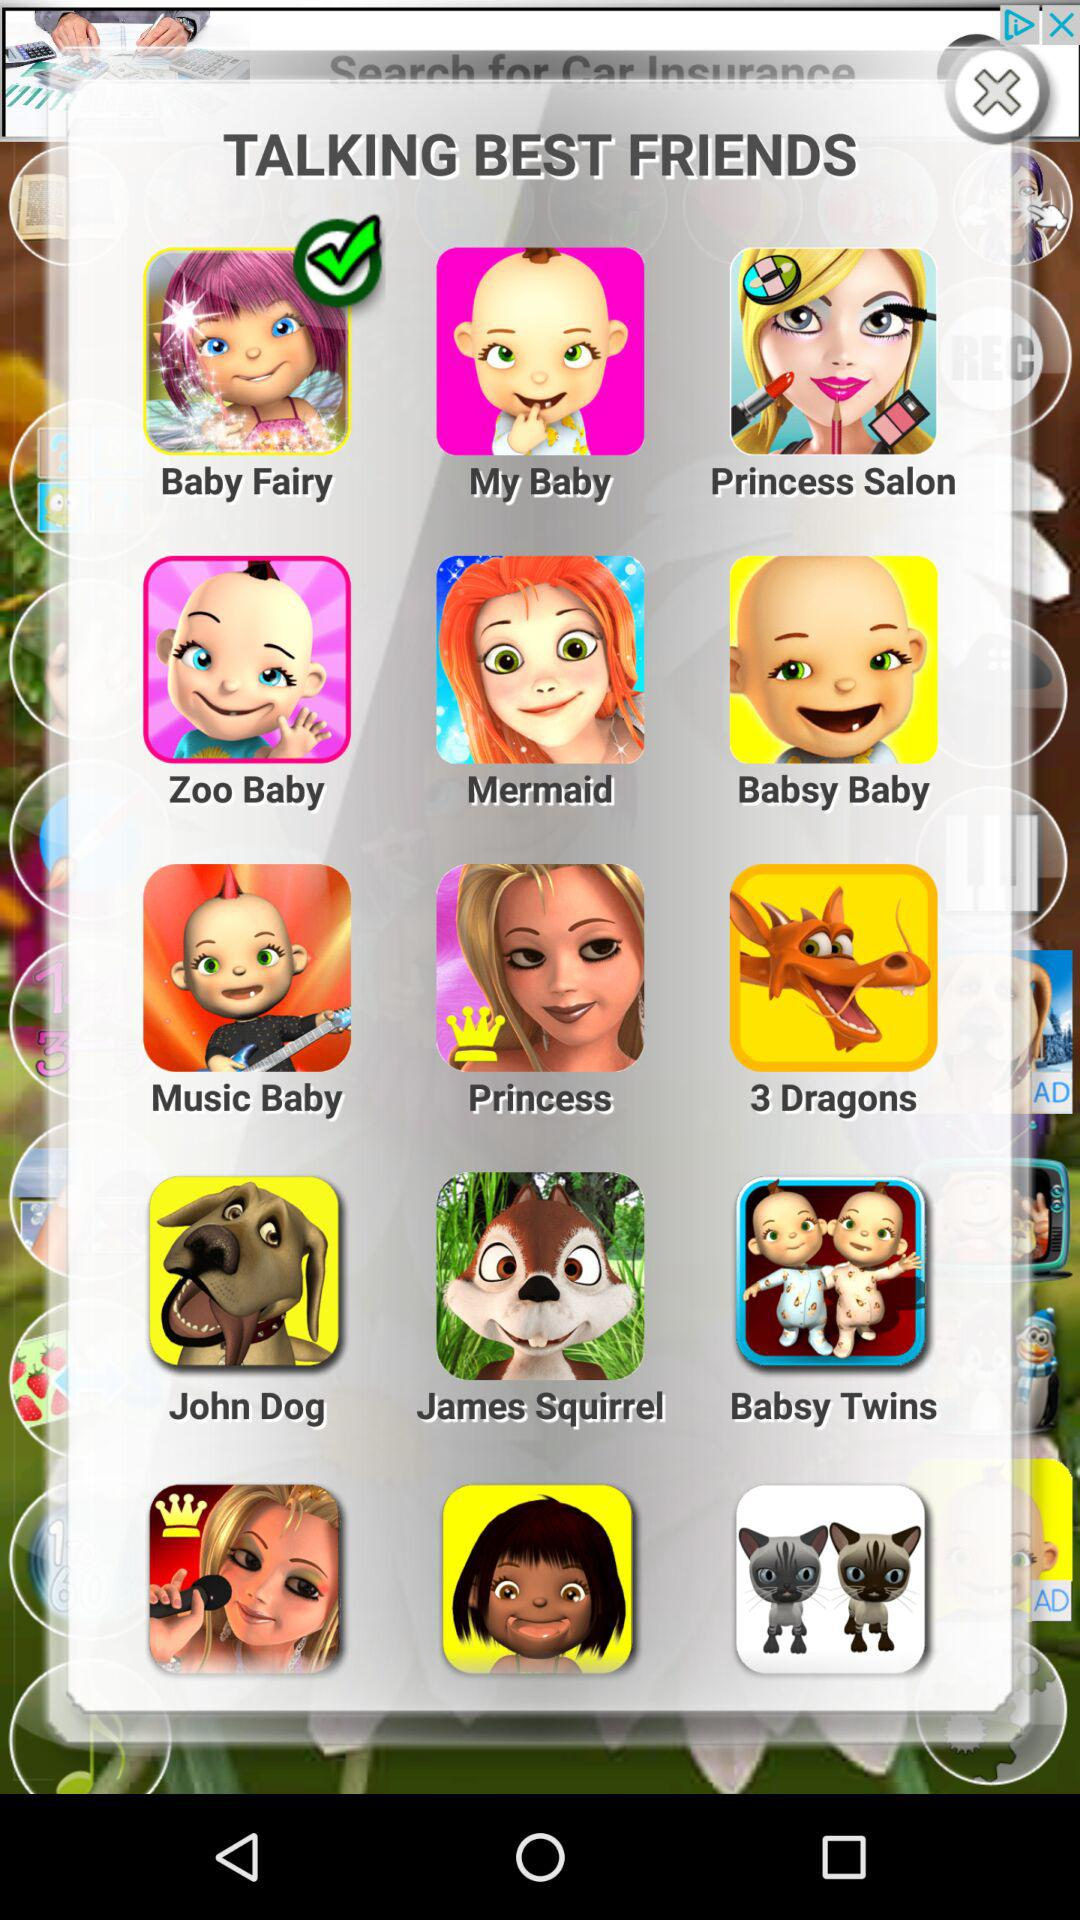What options are there for "TALKING BEST FRIENDS"? The options for "TALKING BEST FRIENDS" are "Baby Fairy", "My Baby", "Princess Salon", "Zoo Baby", "Mermaid", "Babsy Baby", "Music Baby", "Princess", "3 Dragons", "John Dog", "James Squirrel" and "Babsy Twins". 